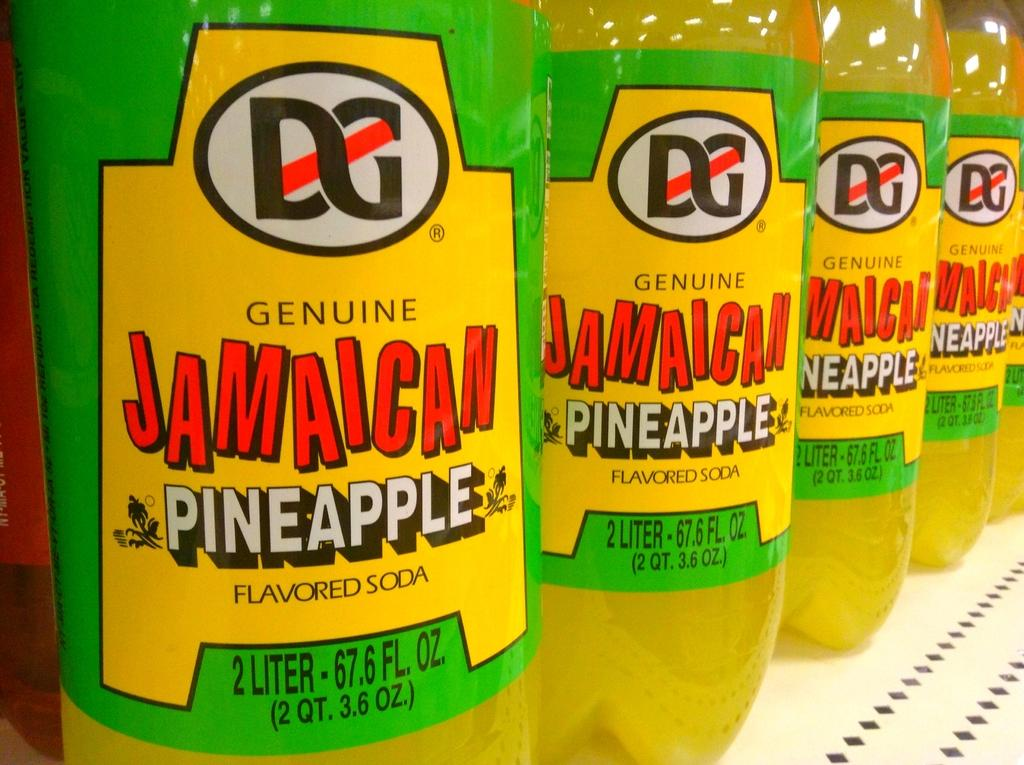<image>
Share a concise interpretation of the image provided. a Jamaican pineapple drink along with many others 